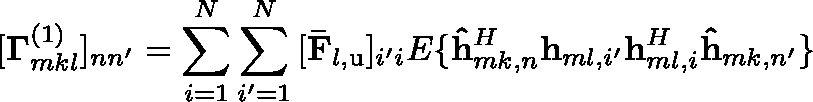Convert formula to latex. <formula><loc_0><loc_0><loc_500><loc_500>[ \Gamma _ { m k l } ^ { \left ( 1 \right ) } ] _ { n n ^ { \prime } } = \sum _ { i = 1 } ^ { N } { \sum _ { i ^ { \prime } = 1 } ^ { N } { [ \bar { F } _ { l , u } ] _ { i ^ { \prime } i } \mathbb { E } \{ \hat { h } _ { m k , n } ^ { H } h _ { m l , i ^ { \prime } } h _ { m l , i } ^ { H } \hat { h } _ { m k , n ^ { \prime } } \} } }</formula> 